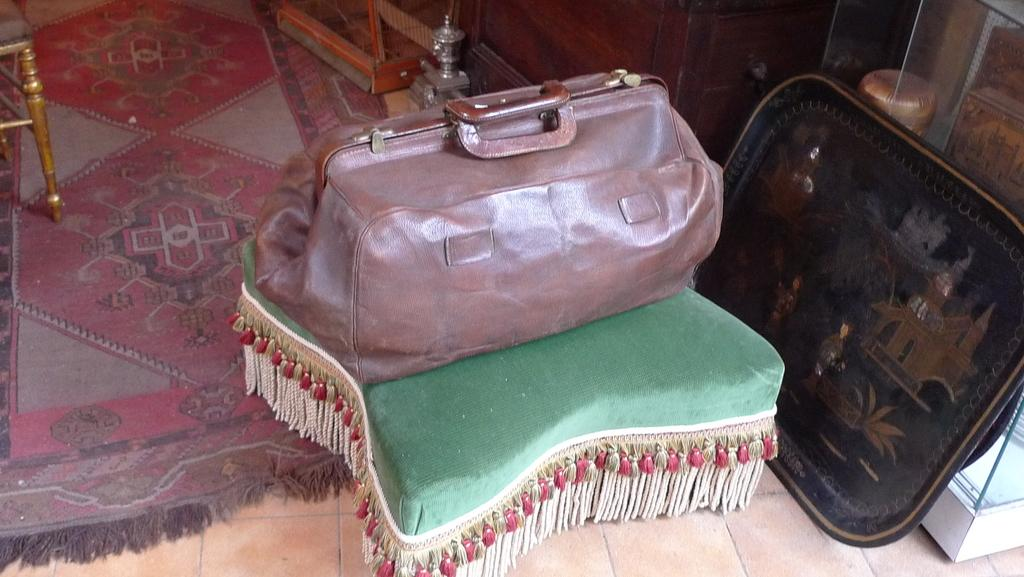What piece of furniture is present in the image? There is a table in the image. What object is placed on the table? There is a bag on the table. How many tomatoes are growing on the mitten in the image? There are no tomatoes or mittens present in the image. 